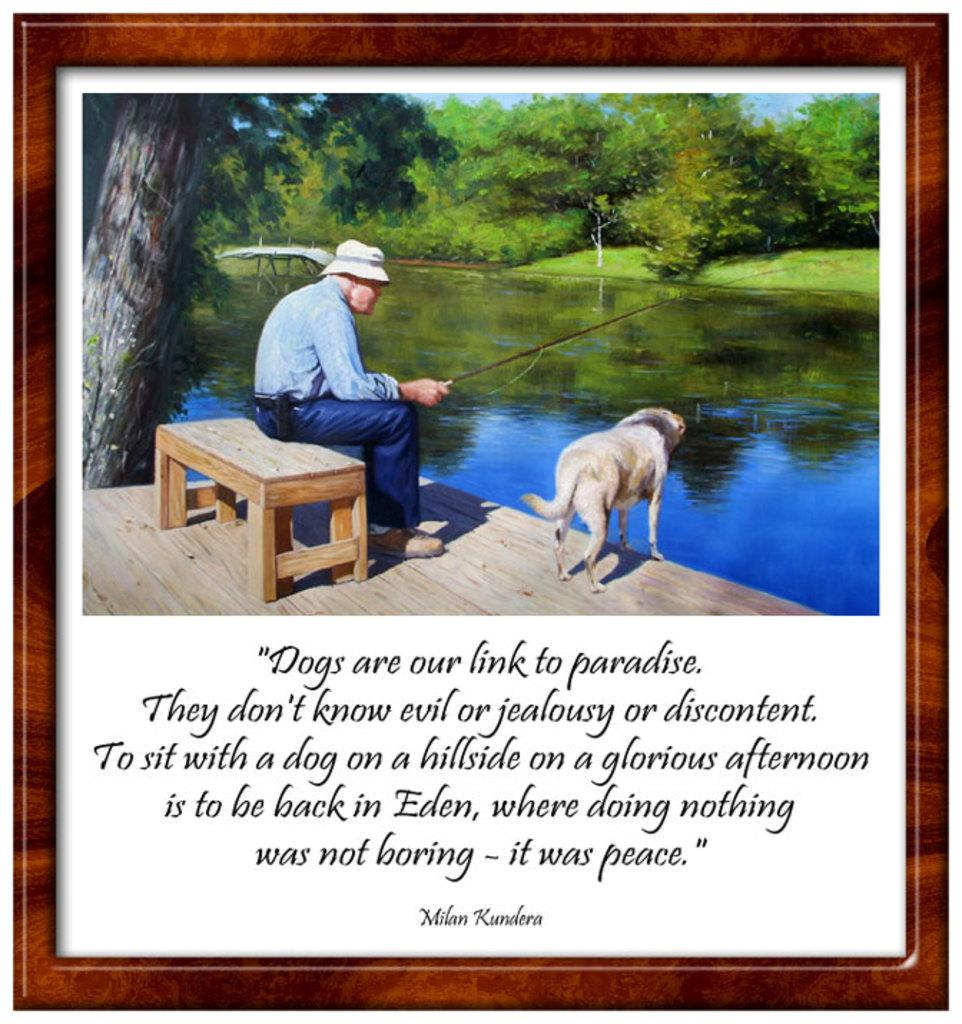<image>
Write a terse but informative summary of the picture. A picture of a man fishing sits above a quote by Milan Kundera. 